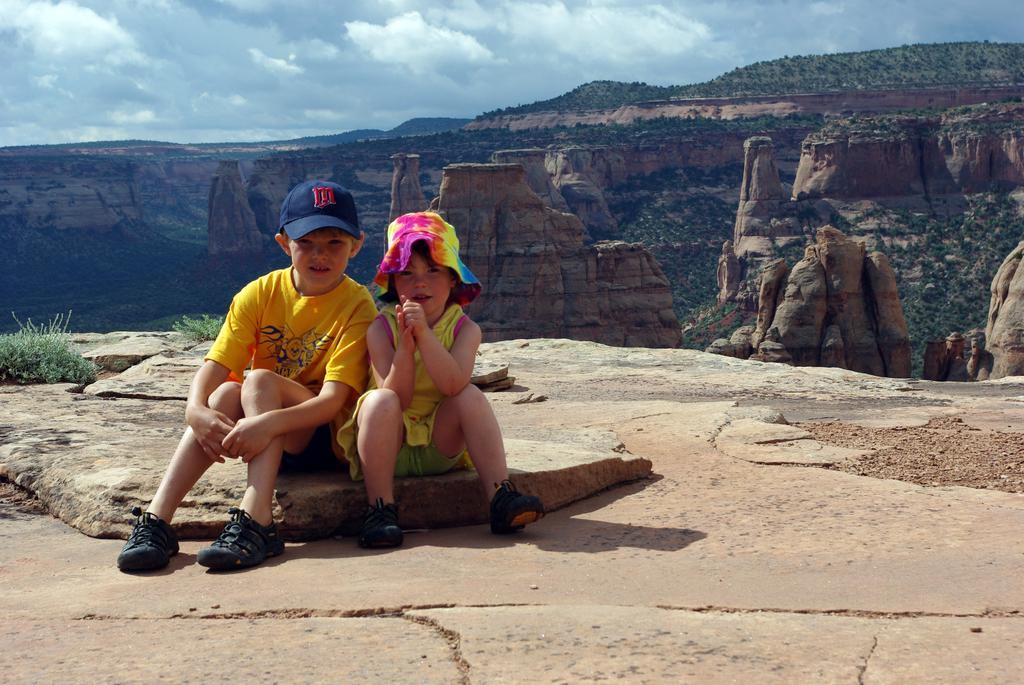How many children are in the image? There are two children in the image. What are the children doing in the image? The children are sitting on a rock. What type of natural features can be seen in the image? Trees, rocks, mountains, and the sky are visible in the image. What color is the grape that the children are holding in the image? There are no grapes present in the image; the children are sitting on a rock. 